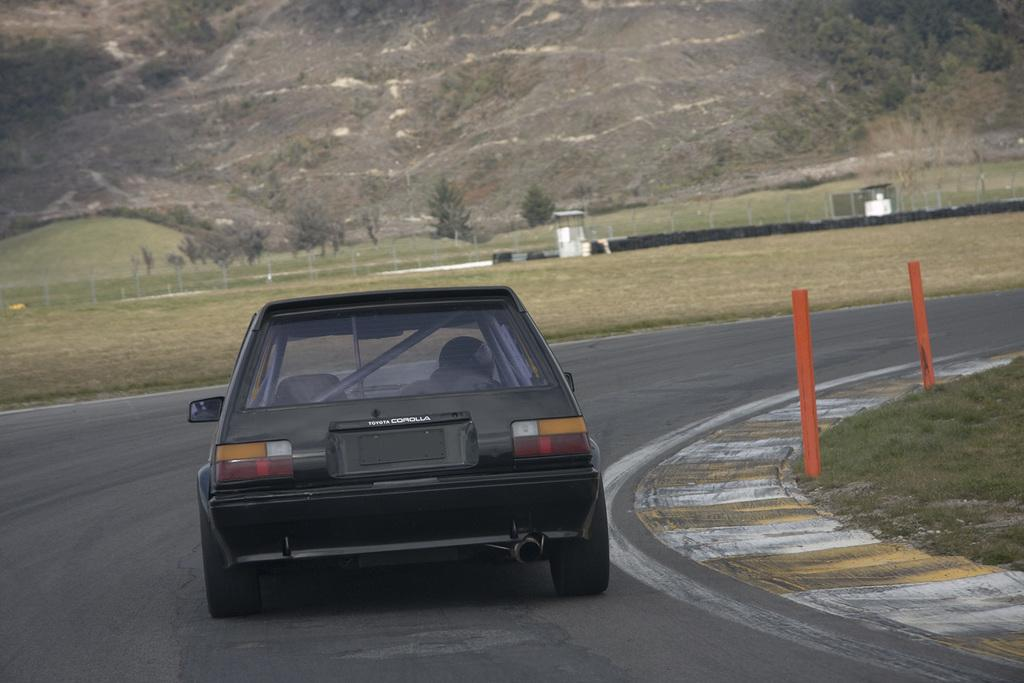What is the main subject of the image? There is a car in the image. Where is the car located? The car is on the road. What can be seen in the background of the image? There are trees visible in the background of the image. How many turkeys are sitting on the car's hood in the image? There are no turkeys present in the image. What form does the car take in the image? The car is in its typical form, as a vehicle for transportation. 